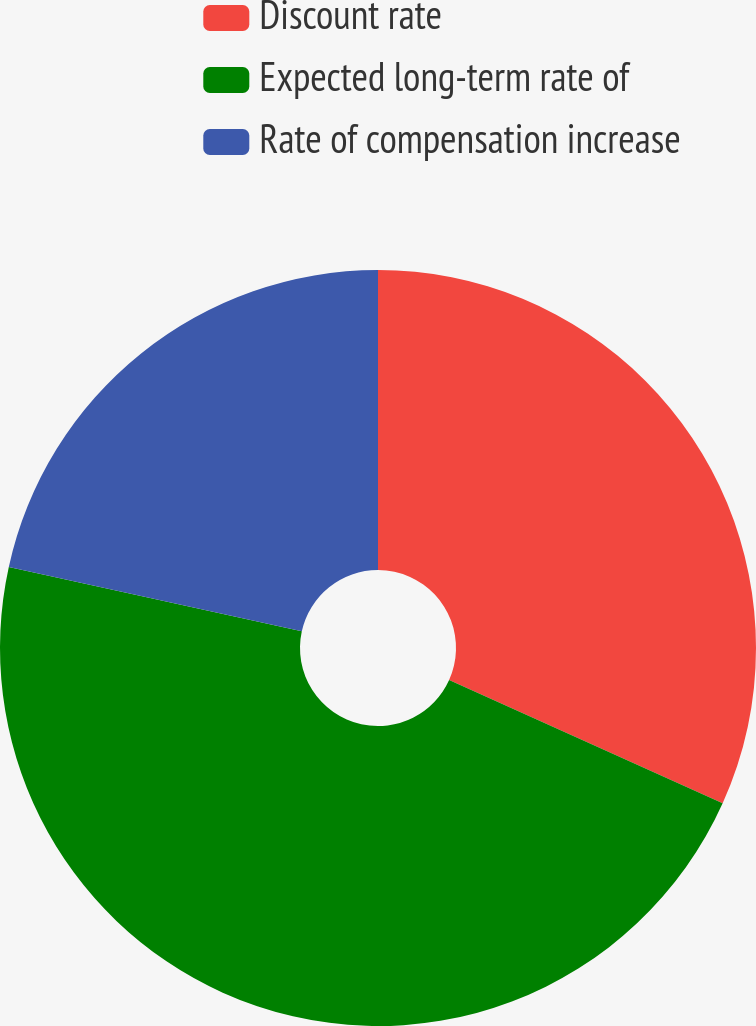Convert chart. <chart><loc_0><loc_0><loc_500><loc_500><pie_chart><fcel>Discount rate<fcel>Expected long-term rate of<fcel>Rate of compensation increase<nl><fcel>31.74%<fcel>46.71%<fcel>21.56%<nl></chart> 